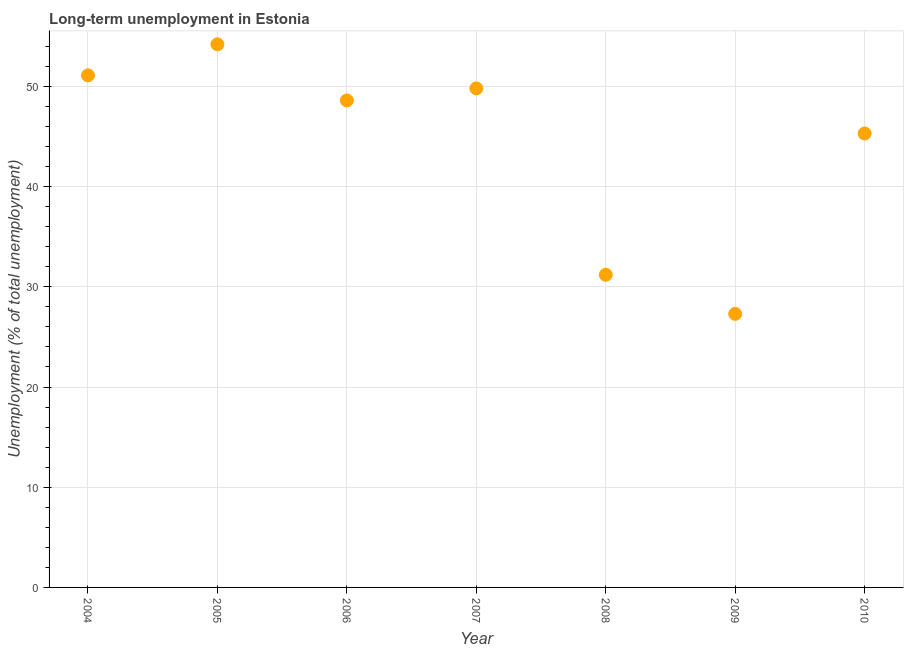What is the long-term unemployment in 2006?
Offer a very short reply. 48.6. Across all years, what is the maximum long-term unemployment?
Give a very brief answer. 54.2. Across all years, what is the minimum long-term unemployment?
Give a very brief answer. 27.3. In which year was the long-term unemployment maximum?
Your answer should be very brief. 2005. In which year was the long-term unemployment minimum?
Offer a very short reply. 2009. What is the sum of the long-term unemployment?
Keep it short and to the point. 307.5. What is the difference between the long-term unemployment in 2005 and 2009?
Make the answer very short. 26.9. What is the average long-term unemployment per year?
Ensure brevity in your answer.  43.93. What is the median long-term unemployment?
Your response must be concise. 48.6. In how many years, is the long-term unemployment greater than 38 %?
Your response must be concise. 5. What is the ratio of the long-term unemployment in 2006 to that in 2010?
Provide a succinct answer. 1.07. Is the long-term unemployment in 2006 less than that in 2010?
Make the answer very short. No. What is the difference between the highest and the second highest long-term unemployment?
Your answer should be compact. 3.1. Is the sum of the long-term unemployment in 2008 and 2010 greater than the maximum long-term unemployment across all years?
Provide a short and direct response. Yes. What is the difference between the highest and the lowest long-term unemployment?
Ensure brevity in your answer.  26.9. In how many years, is the long-term unemployment greater than the average long-term unemployment taken over all years?
Your answer should be compact. 5. How many dotlines are there?
Provide a short and direct response. 1. What is the difference between two consecutive major ticks on the Y-axis?
Provide a succinct answer. 10. Does the graph contain grids?
Ensure brevity in your answer.  Yes. What is the title of the graph?
Your answer should be compact. Long-term unemployment in Estonia. What is the label or title of the Y-axis?
Give a very brief answer. Unemployment (% of total unemployment). What is the Unemployment (% of total unemployment) in 2004?
Offer a terse response. 51.1. What is the Unemployment (% of total unemployment) in 2005?
Offer a terse response. 54.2. What is the Unemployment (% of total unemployment) in 2006?
Your answer should be very brief. 48.6. What is the Unemployment (% of total unemployment) in 2007?
Offer a very short reply. 49.8. What is the Unemployment (% of total unemployment) in 2008?
Make the answer very short. 31.2. What is the Unemployment (% of total unemployment) in 2009?
Offer a terse response. 27.3. What is the Unemployment (% of total unemployment) in 2010?
Your answer should be very brief. 45.3. What is the difference between the Unemployment (% of total unemployment) in 2004 and 2007?
Provide a short and direct response. 1.3. What is the difference between the Unemployment (% of total unemployment) in 2004 and 2008?
Your answer should be very brief. 19.9. What is the difference between the Unemployment (% of total unemployment) in 2004 and 2009?
Make the answer very short. 23.8. What is the difference between the Unemployment (% of total unemployment) in 2004 and 2010?
Your response must be concise. 5.8. What is the difference between the Unemployment (% of total unemployment) in 2005 and 2006?
Make the answer very short. 5.6. What is the difference between the Unemployment (% of total unemployment) in 2005 and 2009?
Your response must be concise. 26.9. What is the difference between the Unemployment (% of total unemployment) in 2006 and 2009?
Offer a very short reply. 21.3. What is the difference between the Unemployment (% of total unemployment) in 2006 and 2010?
Your response must be concise. 3.3. What is the difference between the Unemployment (% of total unemployment) in 2007 and 2009?
Provide a short and direct response. 22.5. What is the difference between the Unemployment (% of total unemployment) in 2007 and 2010?
Provide a short and direct response. 4.5. What is the difference between the Unemployment (% of total unemployment) in 2008 and 2010?
Your response must be concise. -14.1. What is the difference between the Unemployment (% of total unemployment) in 2009 and 2010?
Ensure brevity in your answer.  -18. What is the ratio of the Unemployment (% of total unemployment) in 2004 to that in 2005?
Provide a succinct answer. 0.94. What is the ratio of the Unemployment (% of total unemployment) in 2004 to that in 2006?
Keep it short and to the point. 1.05. What is the ratio of the Unemployment (% of total unemployment) in 2004 to that in 2008?
Your answer should be compact. 1.64. What is the ratio of the Unemployment (% of total unemployment) in 2004 to that in 2009?
Offer a terse response. 1.87. What is the ratio of the Unemployment (% of total unemployment) in 2004 to that in 2010?
Offer a terse response. 1.13. What is the ratio of the Unemployment (% of total unemployment) in 2005 to that in 2006?
Ensure brevity in your answer.  1.11. What is the ratio of the Unemployment (% of total unemployment) in 2005 to that in 2007?
Your answer should be very brief. 1.09. What is the ratio of the Unemployment (% of total unemployment) in 2005 to that in 2008?
Your answer should be compact. 1.74. What is the ratio of the Unemployment (% of total unemployment) in 2005 to that in 2009?
Offer a very short reply. 1.99. What is the ratio of the Unemployment (% of total unemployment) in 2005 to that in 2010?
Make the answer very short. 1.2. What is the ratio of the Unemployment (% of total unemployment) in 2006 to that in 2007?
Your answer should be compact. 0.98. What is the ratio of the Unemployment (% of total unemployment) in 2006 to that in 2008?
Ensure brevity in your answer.  1.56. What is the ratio of the Unemployment (% of total unemployment) in 2006 to that in 2009?
Offer a terse response. 1.78. What is the ratio of the Unemployment (% of total unemployment) in 2006 to that in 2010?
Your response must be concise. 1.07. What is the ratio of the Unemployment (% of total unemployment) in 2007 to that in 2008?
Offer a very short reply. 1.6. What is the ratio of the Unemployment (% of total unemployment) in 2007 to that in 2009?
Keep it short and to the point. 1.82. What is the ratio of the Unemployment (% of total unemployment) in 2007 to that in 2010?
Your answer should be compact. 1.1. What is the ratio of the Unemployment (% of total unemployment) in 2008 to that in 2009?
Offer a very short reply. 1.14. What is the ratio of the Unemployment (% of total unemployment) in 2008 to that in 2010?
Provide a succinct answer. 0.69. What is the ratio of the Unemployment (% of total unemployment) in 2009 to that in 2010?
Offer a very short reply. 0.6. 